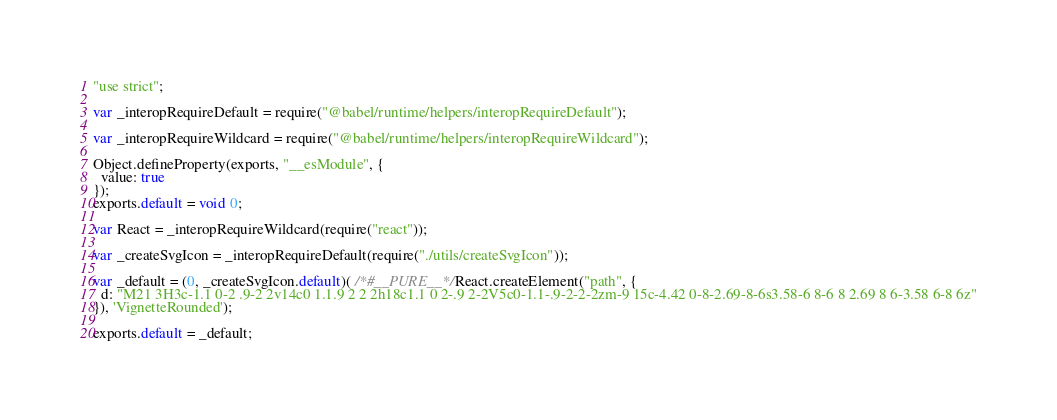<code> <loc_0><loc_0><loc_500><loc_500><_JavaScript_>"use strict";

var _interopRequireDefault = require("@babel/runtime/helpers/interopRequireDefault");

var _interopRequireWildcard = require("@babel/runtime/helpers/interopRequireWildcard");

Object.defineProperty(exports, "__esModule", {
  value: true
});
exports.default = void 0;

var React = _interopRequireWildcard(require("react"));

var _createSvgIcon = _interopRequireDefault(require("./utils/createSvgIcon"));

var _default = (0, _createSvgIcon.default)( /*#__PURE__*/React.createElement("path", {
  d: "M21 3H3c-1.1 0-2 .9-2 2v14c0 1.1.9 2 2 2h18c1.1 0 2-.9 2-2V5c0-1.1-.9-2-2-2zm-9 15c-4.42 0-8-2.69-8-6s3.58-6 8-6 8 2.69 8 6-3.58 6-8 6z"
}), 'VignetteRounded');

exports.default = _default;</code> 